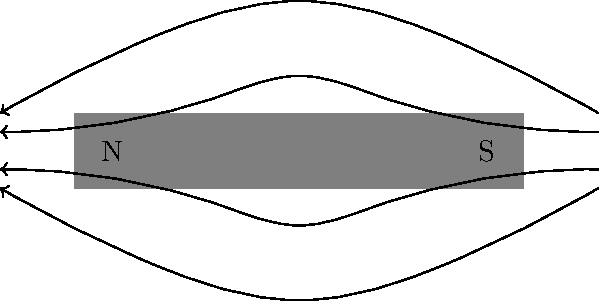In the context of Argentina's scientific development during the post-dictatorship era, consider the magnetic field lines around a bar magnet shown in the diagram. How do these field lines demonstrate the dipole nature of magnetism, and what implications might this have for technological advancements in both Argentina and Venezuela? To understand how the magnetic field lines demonstrate the dipole nature of magnetism, let's break it down step-by-step:

1. Direction of field lines: The field lines emerge from the North pole (N) and enter the South pole (S) of the magnet. This shows that magnetism always has two poles, hence the term "dipole."

2. Closed loops: The field lines form closed loops, never intersecting each other. This indicates that magnetic monopoles do not exist in nature.

3. Density of field lines: The field lines are more concentrated near the poles, indicating stronger magnetic field strength in these regions.

4. Symmetry: The field lines are symmetrical around the axis of the magnet, showing that the magnetic field is uniform around the magnet.

5. Continuity: The field lines are continuous from one pole to the other, both inside and outside the magnet, demonstrating the continuity of the magnetic field.

Implications for technological advancements:

1. In Argentina: Post-dictatorship, understanding magnetism could contribute to developing technologies like:
   a) Magnetic Resonance Imaging (MRI) for healthcare
   b) Magnetic levitation for transportation

2. In Venezuela: Similar applications could be developed, potentially leading to:
   a) Improved oil exploration techniques using magnetic surveys
   b) Advanced electric power generation and distribution systems

3. Collaboration potential: Both countries could benefit from shared research and development in areas like:
   a) Renewable energy technologies using magnetic components
   b) Data storage devices based on magnetic principles

Understanding the dipole nature of magnetism is crucial for these advancements, as it forms the basis for many magnetic applications in technology and industry.
Answer: The field lines emerge from the North pole, enter the South pole, form closed loops, and are symmetrical and continuous, demonstrating magnetism's dipole nature. 